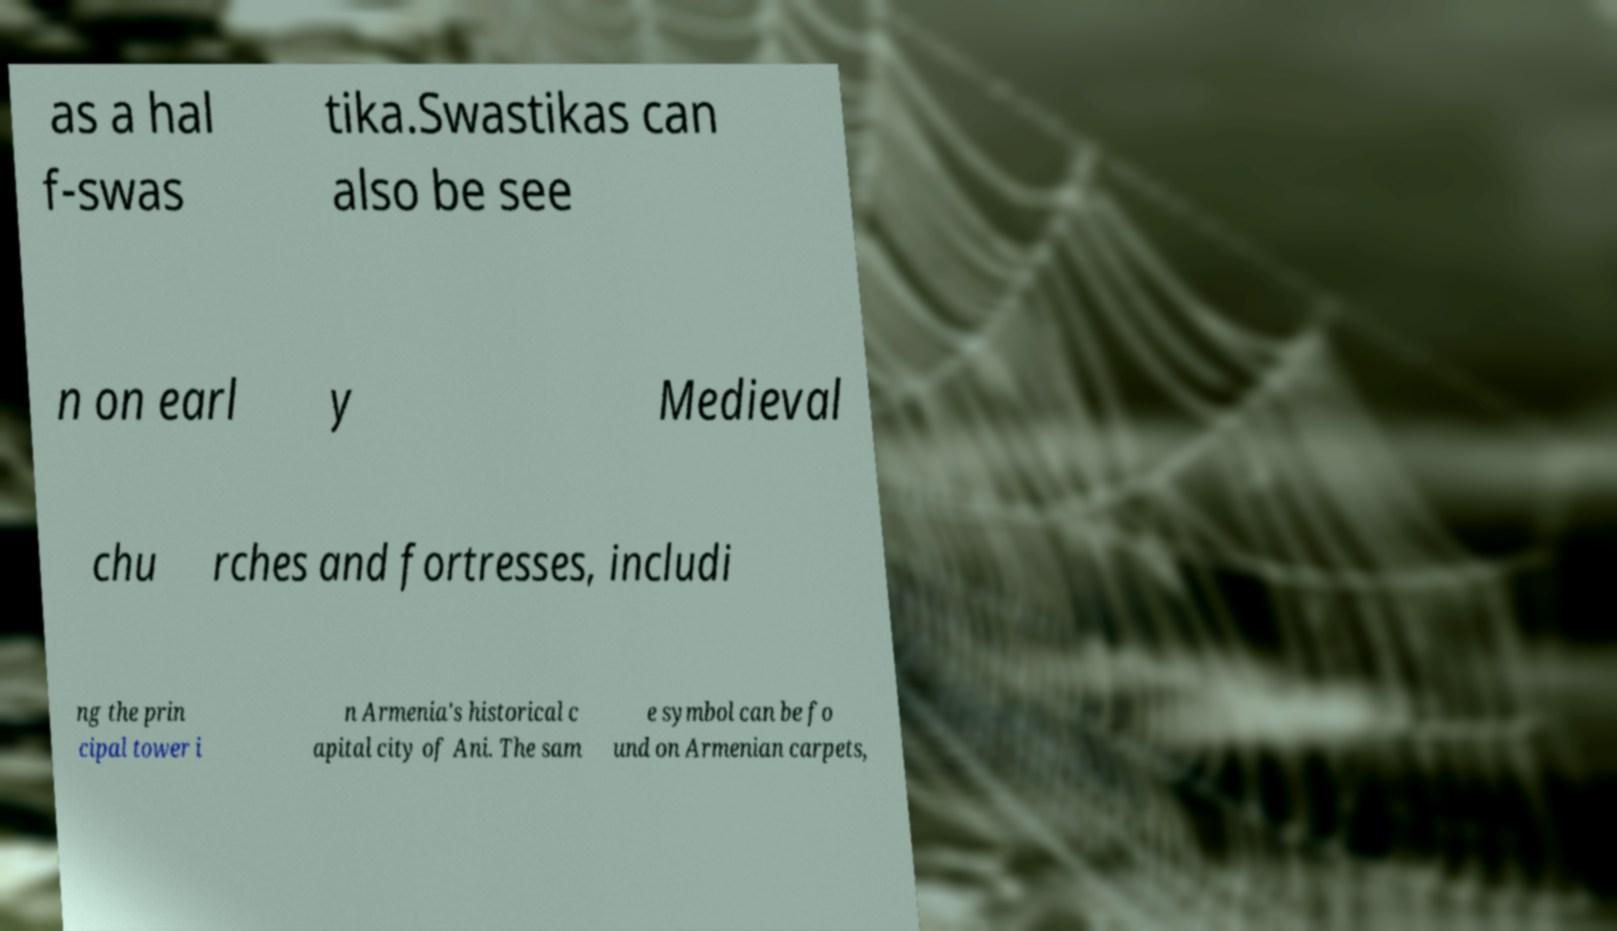Could you extract and type out the text from this image? as a hal f-swas tika.Swastikas can also be see n on earl y Medieval chu rches and fortresses, includi ng the prin cipal tower i n Armenia's historical c apital city of Ani. The sam e symbol can be fo und on Armenian carpets, 